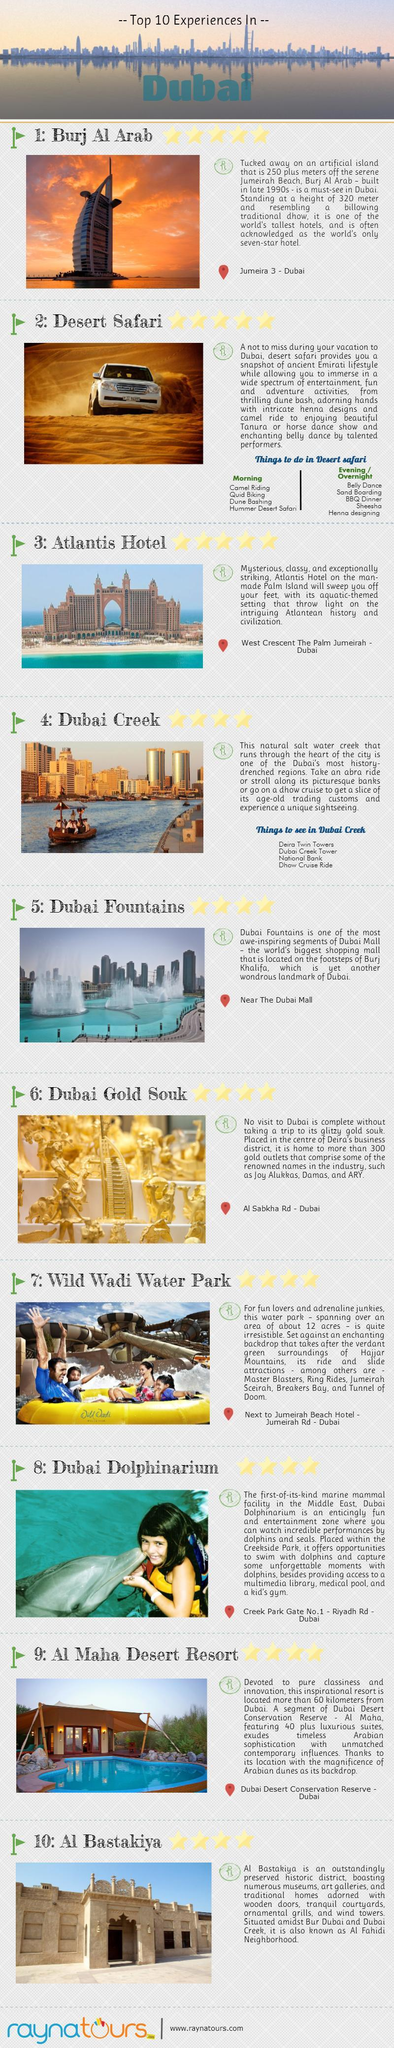Which hotel is built on the man made Palm Island in Dubai?
Answer the question with a short phrase. Atlantis Hotel Where is the Burj Al Arab located in Dubai? Jumeira 3 - Dubai Where is the Dubai Gold Souk located? Al Sabkha Rd - Dubai Which place in dubai provide Dhow Cruise Ride? Dubai Creek What is Al Bastakiya  distirct in dubai otherwise called as? Al Fahidi Neighborhood 